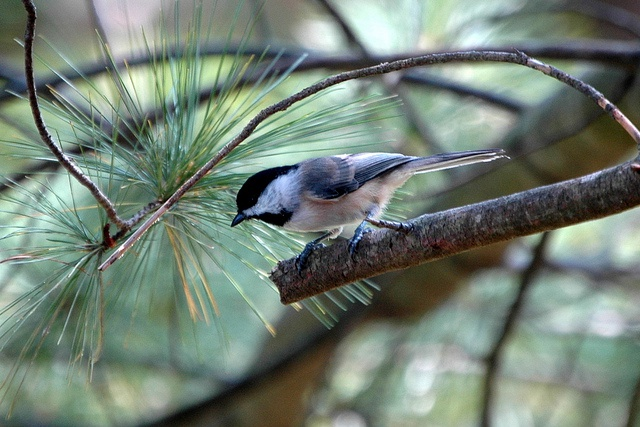Describe the objects in this image and their specific colors. I can see a bird in darkgreen, gray, black, and darkgray tones in this image. 